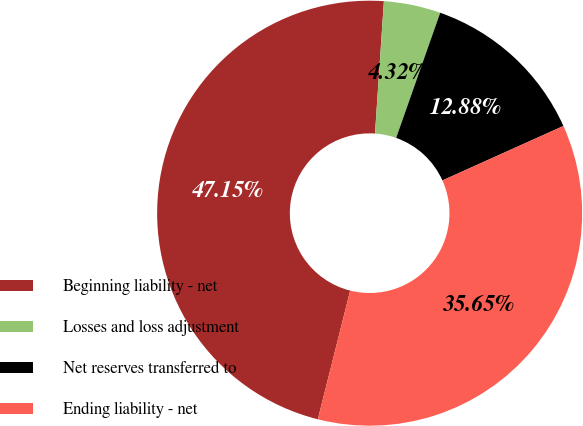<chart> <loc_0><loc_0><loc_500><loc_500><pie_chart><fcel>Beginning liability - net<fcel>Losses and loss adjustment<fcel>Net reserves transferred to<fcel>Ending liability - net<nl><fcel>47.15%<fcel>4.32%<fcel>12.88%<fcel>35.65%<nl></chart> 